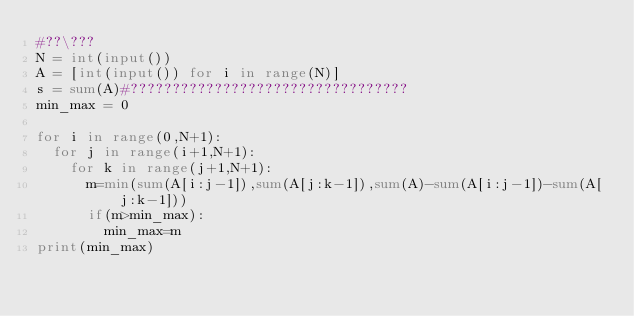Convert code to text. <code><loc_0><loc_0><loc_500><loc_500><_Python_>#??\???
N = int(input())
A = [int(input()) for i in range(N)]
s = sum(A)#?????????????????????????????????
min_max = 0

for i in range(0,N+1):
	for j in range(i+1,N+1):
		for k in range(j+1,N+1):
			m=min(sum(A[i:j-1]),sum(A[j:k-1]),sum(A)-sum(A[i:j-1])-sum(A[j:k-1]))
			if(m>min_max):
				min_max=m
print(min_max)</code> 